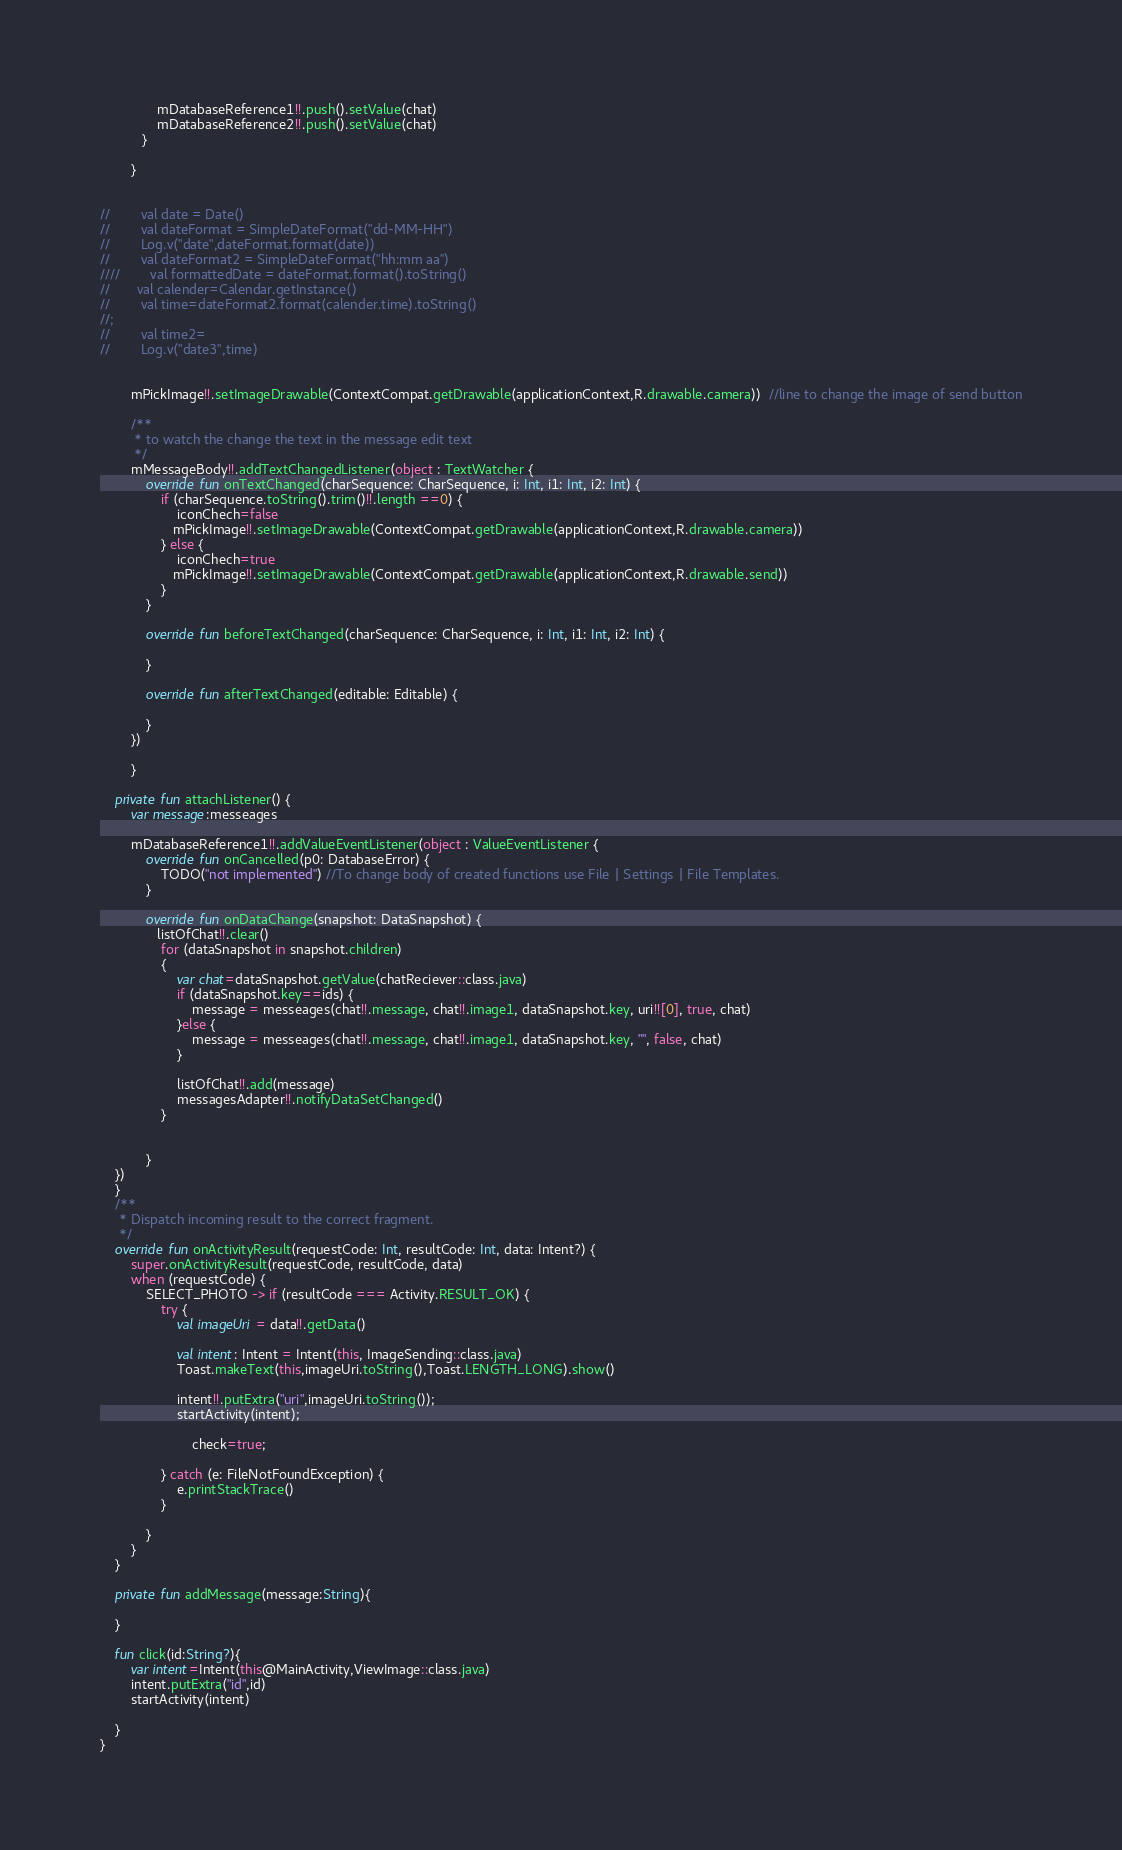<code> <loc_0><loc_0><loc_500><loc_500><_Kotlin_>               mDatabaseReference1!!.push().setValue(chat)
               mDatabaseReference2!!.push().setValue(chat)
           }

        }


//        val date = Date()
//        val dateFormat = SimpleDateFormat("dd-MM-HH")
//        Log.v("date",dateFormat.format(date))
//        val dateFormat2 = SimpleDateFormat("hh:mm aa")
////        val formattedDate = dateFormat.format().toString()
//       val calender=Calendar.getInstance()
//        val time=dateFormat2.format(calender.time).toString()
//;
//        val time2=
//        Log.v("date3",time)


        mPickImage!!.setImageDrawable(ContextCompat.getDrawable(applicationContext,R.drawable.camera))  //line to change the image of send button

        /**
         * to watch the change the text in the message edit text
         */
        mMessageBody!!.addTextChangedListener(object : TextWatcher {
            override fun onTextChanged(charSequence: CharSequence, i: Int, i1: Int, i2: Int) {
                if (charSequence.toString().trim()!!.length ==0) {
                    iconChech=false
                   mPickImage!!.setImageDrawable(ContextCompat.getDrawable(applicationContext,R.drawable.camera))
                } else {
                    iconChech=true
                   mPickImage!!.setImageDrawable(ContextCompat.getDrawable(applicationContext,R.drawable.send))
                }
            }

            override fun beforeTextChanged(charSequence: CharSequence, i: Int, i1: Int, i2: Int) {

            }

            override fun afterTextChanged(editable: Editable) {

            }
        })

        }

    private fun attachListener() {
        var message:messeages

        mDatabaseReference1!!.addValueEventListener(object : ValueEventListener {
            override fun onCancelled(p0: DatabaseError) {
                TODO("not implemented") //To change body of created functions use File | Settings | File Templates.
            }

            override fun onDataChange(snapshot: DataSnapshot) {
               listOfChat!!.clear()
                for (dataSnapshot in snapshot.children)
                {
                    var chat=dataSnapshot.getValue(chatReciever::class.java)
                    if (dataSnapshot.key==ids) {
                        message = messeages(chat!!.message, chat!!.image1, dataSnapshot.key, uri!![0], true, chat)
                    }else {
                        message = messeages(chat!!.message, chat!!.image1, dataSnapshot.key, "", false, chat)
                    }

                    listOfChat!!.add(message)
                    messagesAdapter!!.notifyDataSetChanged()
                }


            }
    })
    }
    /**
     * Dispatch incoming result to the correct fragment.
     */
    override fun onActivityResult(requestCode: Int, resultCode: Int, data: Intent?) {
        super.onActivityResult(requestCode, resultCode, data)
        when (requestCode) {
            SELECT_PHOTO -> if (resultCode === Activity.RESULT_OK) {
                try {
                    val imageUri = data!!.getData()

                    val intent: Intent = Intent(this, ImageSending::class.java)
                    Toast.makeText(this,imageUri.toString(),Toast.LENGTH_LONG).show()

                    intent!!.putExtra("uri",imageUri.toString());
                    startActivity(intent);

                        check=true;

                } catch (e: FileNotFoundException) {
                    e.printStackTrace()
                }

            }
        }
    }

    private fun addMessage(message:String){

    }

    fun click(id:String?){
        var intent=Intent(this@MainActivity,ViewImage::class.java)
        intent.putExtra("id",id)
        startActivity(intent)

    }
}
</code> 